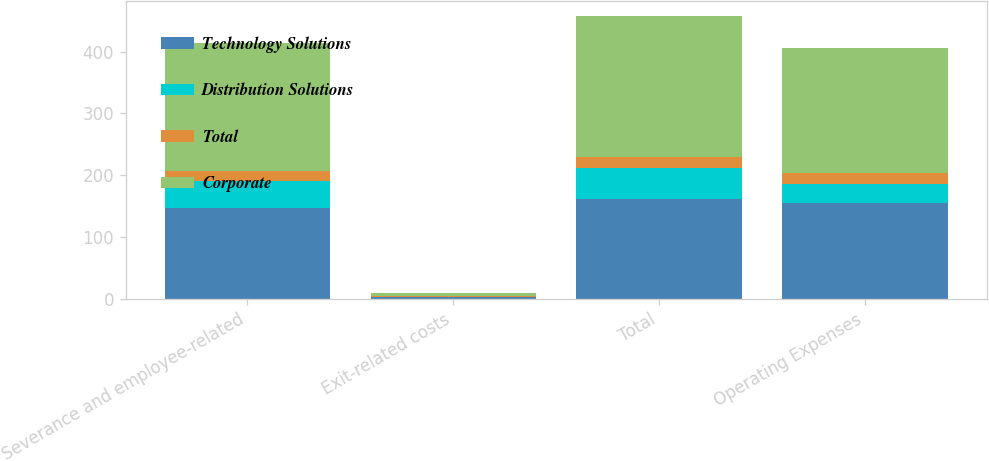<chart> <loc_0><loc_0><loc_500><loc_500><stacked_bar_chart><ecel><fcel>Severance and employee-related<fcel>Exit-related costs<fcel>Total<fcel>Operating Expenses<nl><fcel>Technology Solutions<fcel>147<fcel>3<fcel>161<fcel>156<nl><fcel>Distribution Solutions<fcel>44<fcel>1<fcel>51<fcel>30<nl><fcel>Total<fcel>16<fcel>1<fcel>17<fcel>17<nl><fcel>Corporate<fcel>207<fcel>5<fcel>229<fcel>203<nl></chart> 